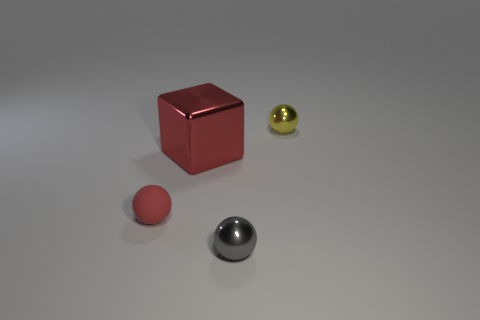What is the color of the small shiny sphere in front of the tiny red sphere?
Your answer should be compact. Gray. How big is the red block?
Provide a succinct answer. Large. There is a big block; is it the same color as the thing that is left of the red metal cube?
Provide a short and direct response. Yes. What color is the tiny metallic object that is in front of the tiny ball on the right side of the gray thing?
Offer a terse response. Gray. Are there any other things that have the same size as the block?
Provide a short and direct response. No. Does the tiny object on the right side of the tiny gray object have the same shape as the big red shiny object?
Provide a succinct answer. No. How many small things are in front of the tiny matte sphere and behind the matte object?
Offer a very short reply. 0. What is the color of the metallic sphere that is to the right of the small shiny object that is in front of the tiny shiny thing behind the tiny gray metal thing?
Make the answer very short. Yellow. How many tiny spheres are left of the metallic ball to the left of the tiny yellow object?
Keep it short and to the point. 1. How many other things are the same shape as the tiny gray object?
Offer a terse response. 2. 